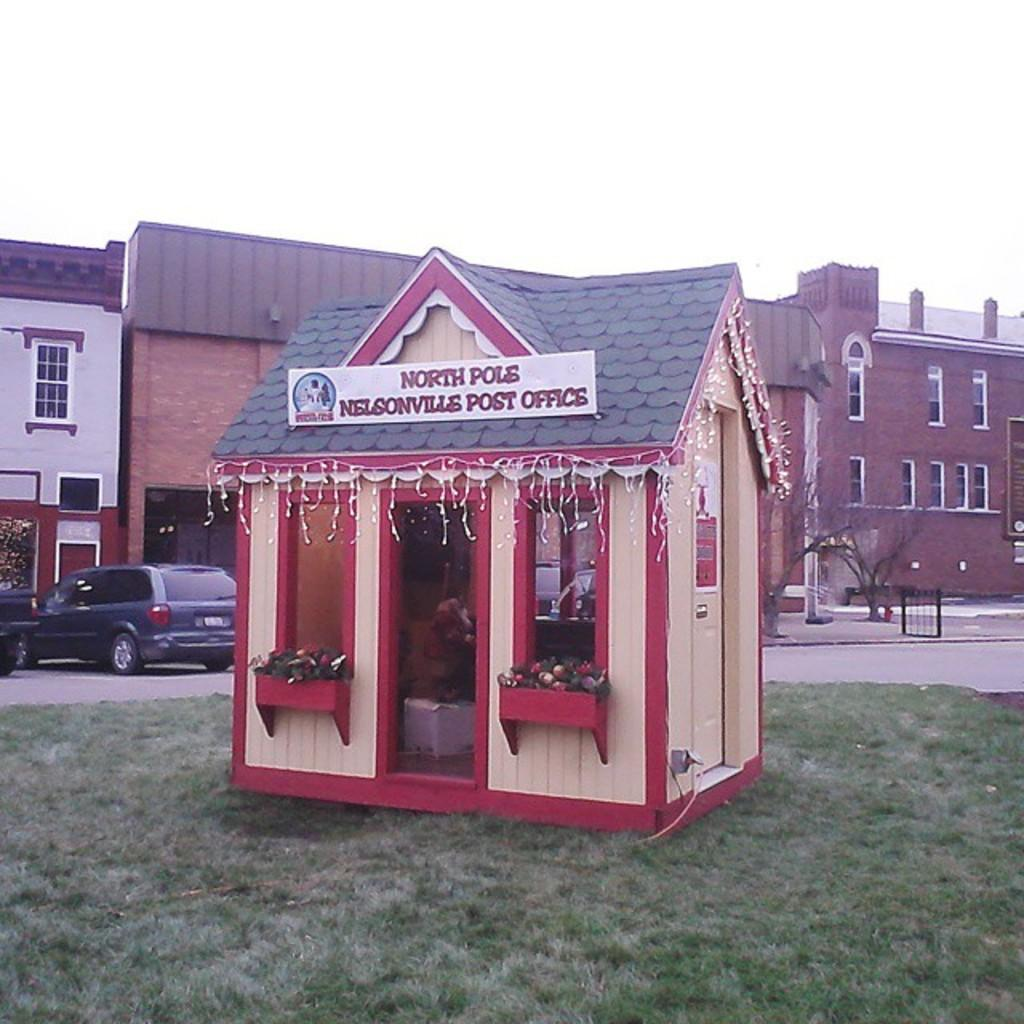What type of structures can be seen in the image? There are buildings in the image. What is located in the center of the image? There is a shed in the center of the image. What vehicles are visible on the left side of the image? There are cars on the left side of the image. What type of vegetation is at the bottom of the image? There is grass at the bottom of the image. What can be seen in the background of the image? The sky and trees are visible in the background of the image. What type of jeans is the engine wearing in the image? There is no engine or jeans present in the image. What condition is the shed in, and how does it affect the functionality of the buildings? The condition of the shed cannot be determined from the image, and there is no information about the functionality of the buildings. 